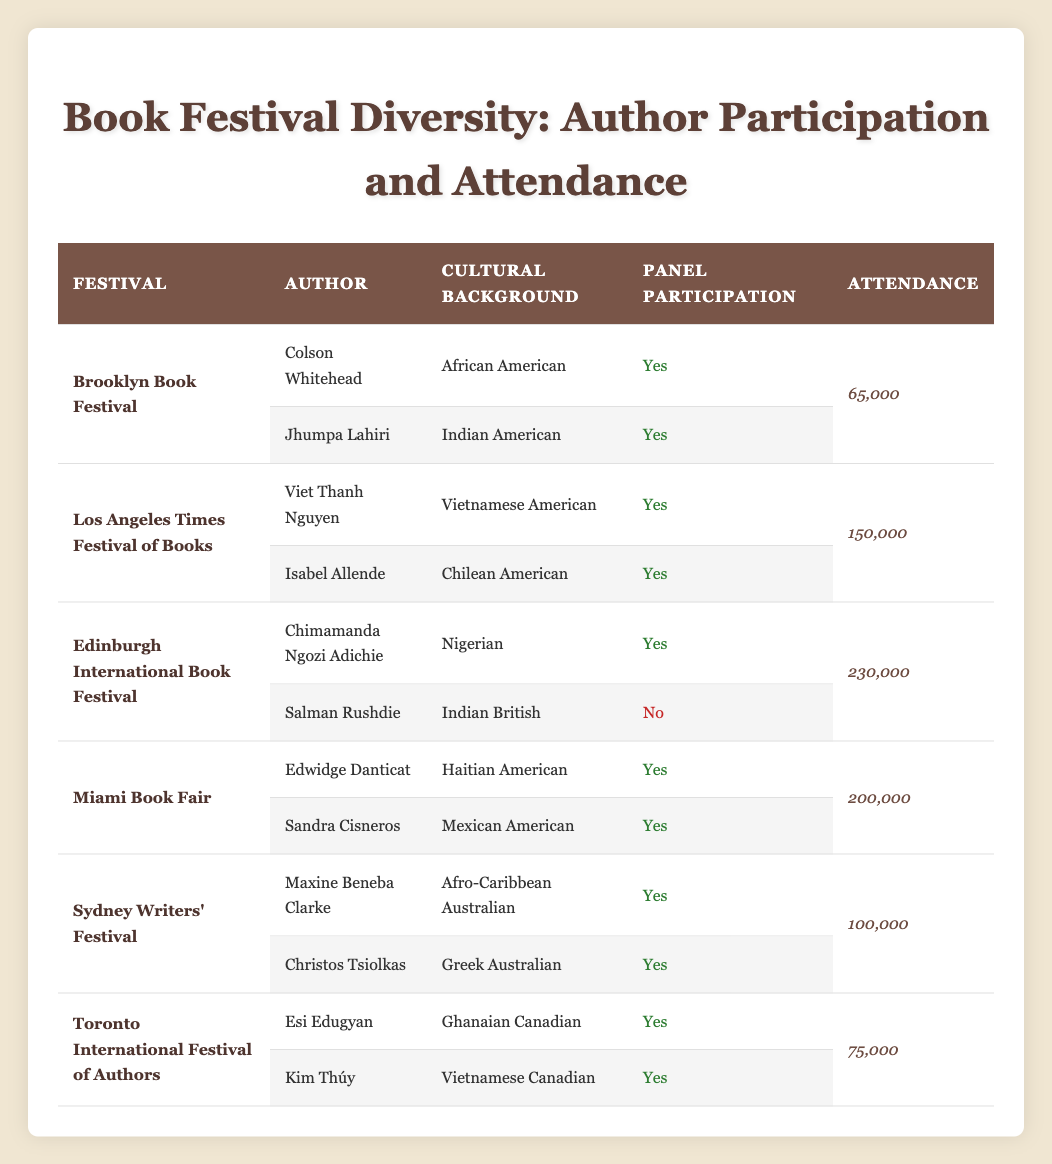What is the total attendance for the Brooklyn Book Festival? The Brooklyn Book Festival has two authors participating: Colson Whitehead and Jhumpa Lahiri. Both have the same attendance listed, which is 65,000. Therefore, the total attendance for the Brooklyn Book Festival is just 65,000 since it's the same for both authors.
Answer: 65,000 How many authors from the festival have an Indian cultural background? There are two authors at the festivals with an Indian cultural background: Jhumpa Lahiri from the Brooklyn Book Festival and Salman Rushdie from the Edinburgh International Book Festival. Since Rushdie did not participate in a panel, we only count Lahiri. Therefore, the total count is one author.
Answer: 1 What is the average attendance of authors from the Miami Book Fair? The Miami Book Fair includes two authors: Edwidge Danticat and Sandra Cisneros, both with an attendance of 200,000. To find the average, we sum the attendance (200,000 + 200,000 = 400,000) and then divide by the number of authors (2). Thus, the average attendance is 400,000/2 = 200,000.
Answer: 200,000 Did any of the authors at the Sydney Writers' Festival not participate in their panel? Both authors listed for the Sydney Writers' Festival, Maxine Beneba Clarke and Christos Tsiolkas, are indicated as having participated in their panels. Therefore, the answer is no, there are no authors at the Sydney Writers' Festival who did not participate in their panel.
Answer: No Which festival had the highest attendance and what was that number? The festival with the highest attendance is the Edinburgh International Book Festival, with a total attendance of 230,000. This is confirmed by reviewing the attendance figures for each festival in the table.
Answer: 230,000 How many authors with a Hispanic cultural background participated in the festivals? The table features two authors from Hispanic backgrounds: Isabel Allende (Chilean American) and Sandra Cisneros (Mexican American), both of whom participated in their respective panels. Therefore, there are two authors from a Hispanic cultural background.
Answer: 2 What percentage of total attendance is represented by the authors of African and Indian descent combined at the Brooklyn Book Festival and the Edinburgh International Book Festival? The Brooklyn Book Festival has an attendance of 65,000, and both authors (Colson Whitehead and Jhumpa Lahiri) belong to African and Indian descent respectively. The Edinburgh International Book Festival has one African author, Chimamanda Ngozi Adichie, whose attendance is 230,000. Adding these together gives us 65,000 + 230,000 = 295,000. The total attendance across all festivals is 1,350,000 (65,000 + 150,000 + 230,000 + 200,000 + 100,000 + 75,000). To find the percentage: (295,000 / 1,350,000) * 100 = 21.85%.
Answer: 21.85% 